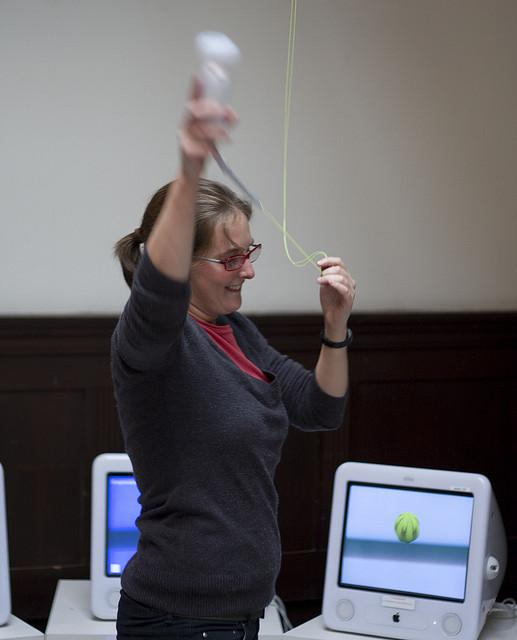What kind of computer is near the woman in blue? apple 